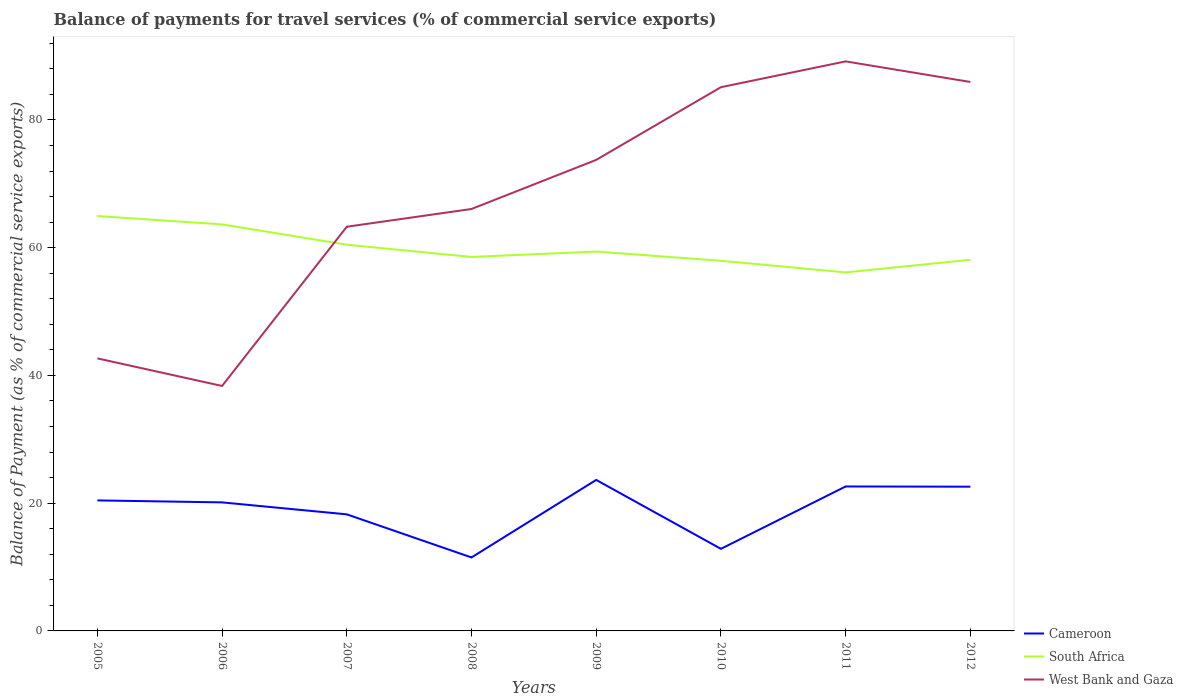How many different coloured lines are there?
Keep it short and to the point. 3. Does the line corresponding to South Africa intersect with the line corresponding to West Bank and Gaza?
Ensure brevity in your answer.  Yes. Across all years, what is the maximum balance of payments for travel services in Cameroon?
Your response must be concise. 11.5. In which year was the balance of payments for travel services in South Africa maximum?
Offer a terse response. 2011. What is the total balance of payments for travel services in South Africa in the graph?
Your answer should be compact. 0.6. What is the difference between the highest and the second highest balance of payments for travel services in South Africa?
Your response must be concise. 8.83. Is the balance of payments for travel services in West Bank and Gaza strictly greater than the balance of payments for travel services in Cameroon over the years?
Offer a terse response. No. How many lines are there?
Offer a very short reply. 3. What is the difference between two consecutive major ticks on the Y-axis?
Provide a succinct answer. 20. Are the values on the major ticks of Y-axis written in scientific E-notation?
Your response must be concise. No. Does the graph contain any zero values?
Make the answer very short. No. Where does the legend appear in the graph?
Your response must be concise. Bottom right. How are the legend labels stacked?
Your answer should be very brief. Vertical. What is the title of the graph?
Make the answer very short. Balance of payments for travel services (% of commercial service exports). Does "Cambodia" appear as one of the legend labels in the graph?
Provide a succinct answer. No. What is the label or title of the Y-axis?
Ensure brevity in your answer.  Balance of Payment (as % of commercial service exports). What is the Balance of Payment (as % of commercial service exports) of Cameroon in 2005?
Your answer should be compact. 20.43. What is the Balance of Payment (as % of commercial service exports) in South Africa in 2005?
Your answer should be compact. 64.96. What is the Balance of Payment (as % of commercial service exports) of West Bank and Gaza in 2005?
Ensure brevity in your answer.  42.67. What is the Balance of Payment (as % of commercial service exports) in Cameroon in 2006?
Your answer should be very brief. 20.13. What is the Balance of Payment (as % of commercial service exports) of South Africa in 2006?
Offer a terse response. 63.65. What is the Balance of Payment (as % of commercial service exports) of West Bank and Gaza in 2006?
Keep it short and to the point. 38.35. What is the Balance of Payment (as % of commercial service exports) in Cameroon in 2007?
Offer a very short reply. 18.25. What is the Balance of Payment (as % of commercial service exports) of South Africa in 2007?
Provide a succinct answer. 60.46. What is the Balance of Payment (as % of commercial service exports) in West Bank and Gaza in 2007?
Your answer should be compact. 63.28. What is the Balance of Payment (as % of commercial service exports) of Cameroon in 2008?
Provide a short and direct response. 11.5. What is the Balance of Payment (as % of commercial service exports) in South Africa in 2008?
Your answer should be compact. 58.55. What is the Balance of Payment (as % of commercial service exports) of West Bank and Gaza in 2008?
Your response must be concise. 66.06. What is the Balance of Payment (as % of commercial service exports) of Cameroon in 2009?
Your answer should be compact. 23.64. What is the Balance of Payment (as % of commercial service exports) of South Africa in 2009?
Ensure brevity in your answer.  59.4. What is the Balance of Payment (as % of commercial service exports) in West Bank and Gaza in 2009?
Offer a very short reply. 73.75. What is the Balance of Payment (as % of commercial service exports) of Cameroon in 2010?
Ensure brevity in your answer.  12.85. What is the Balance of Payment (as % of commercial service exports) in South Africa in 2010?
Your response must be concise. 57.95. What is the Balance of Payment (as % of commercial service exports) in West Bank and Gaza in 2010?
Your answer should be very brief. 85.13. What is the Balance of Payment (as % of commercial service exports) of Cameroon in 2011?
Offer a terse response. 22.62. What is the Balance of Payment (as % of commercial service exports) in South Africa in 2011?
Offer a terse response. 56.14. What is the Balance of Payment (as % of commercial service exports) of West Bank and Gaza in 2011?
Your answer should be very brief. 89.17. What is the Balance of Payment (as % of commercial service exports) of Cameroon in 2012?
Keep it short and to the point. 22.58. What is the Balance of Payment (as % of commercial service exports) in South Africa in 2012?
Provide a succinct answer. 58.11. What is the Balance of Payment (as % of commercial service exports) of West Bank and Gaza in 2012?
Provide a succinct answer. 85.95. Across all years, what is the maximum Balance of Payment (as % of commercial service exports) in Cameroon?
Your answer should be very brief. 23.64. Across all years, what is the maximum Balance of Payment (as % of commercial service exports) of South Africa?
Ensure brevity in your answer.  64.96. Across all years, what is the maximum Balance of Payment (as % of commercial service exports) in West Bank and Gaza?
Provide a succinct answer. 89.17. Across all years, what is the minimum Balance of Payment (as % of commercial service exports) of Cameroon?
Keep it short and to the point. 11.5. Across all years, what is the minimum Balance of Payment (as % of commercial service exports) in South Africa?
Provide a succinct answer. 56.14. Across all years, what is the minimum Balance of Payment (as % of commercial service exports) of West Bank and Gaza?
Make the answer very short. 38.35. What is the total Balance of Payment (as % of commercial service exports) in Cameroon in the graph?
Give a very brief answer. 152.01. What is the total Balance of Payment (as % of commercial service exports) in South Africa in the graph?
Keep it short and to the point. 479.22. What is the total Balance of Payment (as % of commercial service exports) in West Bank and Gaza in the graph?
Keep it short and to the point. 544.36. What is the difference between the Balance of Payment (as % of commercial service exports) of Cameroon in 2005 and that in 2006?
Offer a terse response. 0.31. What is the difference between the Balance of Payment (as % of commercial service exports) of South Africa in 2005 and that in 2006?
Make the answer very short. 1.31. What is the difference between the Balance of Payment (as % of commercial service exports) in West Bank and Gaza in 2005 and that in 2006?
Offer a terse response. 4.32. What is the difference between the Balance of Payment (as % of commercial service exports) of Cameroon in 2005 and that in 2007?
Offer a terse response. 2.18. What is the difference between the Balance of Payment (as % of commercial service exports) of South Africa in 2005 and that in 2007?
Your answer should be compact. 4.5. What is the difference between the Balance of Payment (as % of commercial service exports) of West Bank and Gaza in 2005 and that in 2007?
Offer a terse response. -20.61. What is the difference between the Balance of Payment (as % of commercial service exports) in Cameroon in 2005 and that in 2008?
Provide a succinct answer. 8.93. What is the difference between the Balance of Payment (as % of commercial service exports) of South Africa in 2005 and that in 2008?
Make the answer very short. 6.41. What is the difference between the Balance of Payment (as % of commercial service exports) in West Bank and Gaza in 2005 and that in 2008?
Provide a short and direct response. -23.39. What is the difference between the Balance of Payment (as % of commercial service exports) of Cameroon in 2005 and that in 2009?
Provide a succinct answer. -3.21. What is the difference between the Balance of Payment (as % of commercial service exports) of South Africa in 2005 and that in 2009?
Provide a succinct answer. 5.56. What is the difference between the Balance of Payment (as % of commercial service exports) of West Bank and Gaza in 2005 and that in 2009?
Make the answer very short. -31.08. What is the difference between the Balance of Payment (as % of commercial service exports) in Cameroon in 2005 and that in 2010?
Your answer should be compact. 7.58. What is the difference between the Balance of Payment (as % of commercial service exports) of South Africa in 2005 and that in 2010?
Give a very brief answer. 7.01. What is the difference between the Balance of Payment (as % of commercial service exports) in West Bank and Gaza in 2005 and that in 2010?
Provide a short and direct response. -42.46. What is the difference between the Balance of Payment (as % of commercial service exports) in Cameroon in 2005 and that in 2011?
Your response must be concise. -2.18. What is the difference between the Balance of Payment (as % of commercial service exports) in South Africa in 2005 and that in 2011?
Offer a very short reply. 8.83. What is the difference between the Balance of Payment (as % of commercial service exports) in West Bank and Gaza in 2005 and that in 2011?
Provide a succinct answer. -46.5. What is the difference between the Balance of Payment (as % of commercial service exports) in Cameroon in 2005 and that in 2012?
Make the answer very short. -2.15. What is the difference between the Balance of Payment (as % of commercial service exports) in South Africa in 2005 and that in 2012?
Offer a very short reply. 6.85. What is the difference between the Balance of Payment (as % of commercial service exports) of West Bank and Gaza in 2005 and that in 2012?
Keep it short and to the point. -43.28. What is the difference between the Balance of Payment (as % of commercial service exports) in Cameroon in 2006 and that in 2007?
Your answer should be very brief. 1.87. What is the difference between the Balance of Payment (as % of commercial service exports) of South Africa in 2006 and that in 2007?
Provide a short and direct response. 3.18. What is the difference between the Balance of Payment (as % of commercial service exports) of West Bank and Gaza in 2006 and that in 2007?
Keep it short and to the point. -24.93. What is the difference between the Balance of Payment (as % of commercial service exports) in Cameroon in 2006 and that in 2008?
Make the answer very short. 8.62. What is the difference between the Balance of Payment (as % of commercial service exports) of South Africa in 2006 and that in 2008?
Your response must be concise. 5.1. What is the difference between the Balance of Payment (as % of commercial service exports) in West Bank and Gaza in 2006 and that in 2008?
Your answer should be very brief. -27.71. What is the difference between the Balance of Payment (as % of commercial service exports) of Cameroon in 2006 and that in 2009?
Your answer should be compact. -3.52. What is the difference between the Balance of Payment (as % of commercial service exports) of South Africa in 2006 and that in 2009?
Make the answer very short. 4.25. What is the difference between the Balance of Payment (as % of commercial service exports) of West Bank and Gaza in 2006 and that in 2009?
Give a very brief answer. -35.4. What is the difference between the Balance of Payment (as % of commercial service exports) in Cameroon in 2006 and that in 2010?
Provide a short and direct response. 7.27. What is the difference between the Balance of Payment (as % of commercial service exports) of South Africa in 2006 and that in 2010?
Your response must be concise. 5.7. What is the difference between the Balance of Payment (as % of commercial service exports) in West Bank and Gaza in 2006 and that in 2010?
Offer a very short reply. -46.78. What is the difference between the Balance of Payment (as % of commercial service exports) in Cameroon in 2006 and that in 2011?
Give a very brief answer. -2.49. What is the difference between the Balance of Payment (as % of commercial service exports) in South Africa in 2006 and that in 2011?
Your response must be concise. 7.51. What is the difference between the Balance of Payment (as % of commercial service exports) in West Bank and Gaza in 2006 and that in 2011?
Your response must be concise. -50.82. What is the difference between the Balance of Payment (as % of commercial service exports) of Cameroon in 2006 and that in 2012?
Ensure brevity in your answer.  -2.46. What is the difference between the Balance of Payment (as % of commercial service exports) of South Africa in 2006 and that in 2012?
Give a very brief answer. 5.54. What is the difference between the Balance of Payment (as % of commercial service exports) of West Bank and Gaza in 2006 and that in 2012?
Keep it short and to the point. -47.6. What is the difference between the Balance of Payment (as % of commercial service exports) of Cameroon in 2007 and that in 2008?
Offer a terse response. 6.75. What is the difference between the Balance of Payment (as % of commercial service exports) in South Africa in 2007 and that in 2008?
Give a very brief answer. 1.91. What is the difference between the Balance of Payment (as % of commercial service exports) of West Bank and Gaza in 2007 and that in 2008?
Ensure brevity in your answer.  -2.78. What is the difference between the Balance of Payment (as % of commercial service exports) in Cameroon in 2007 and that in 2009?
Offer a terse response. -5.39. What is the difference between the Balance of Payment (as % of commercial service exports) in South Africa in 2007 and that in 2009?
Offer a terse response. 1.07. What is the difference between the Balance of Payment (as % of commercial service exports) of West Bank and Gaza in 2007 and that in 2009?
Offer a terse response. -10.47. What is the difference between the Balance of Payment (as % of commercial service exports) in Cameroon in 2007 and that in 2010?
Your answer should be very brief. 5.4. What is the difference between the Balance of Payment (as % of commercial service exports) in South Africa in 2007 and that in 2010?
Keep it short and to the point. 2.51. What is the difference between the Balance of Payment (as % of commercial service exports) in West Bank and Gaza in 2007 and that in 2010?
Keep it short and to the point. -21.85. What is the difference between the Balance of Payment (as % of commercial service exports) in Cameroon in 2007 and that in 2011?
Make the answer very short. -4.36. What is the difference between the Balance of Payment (as % of commercial service exports) in South Africa in 2007 and that in 2011?
Offer a very short reply. 4.33. What is the difference between the Balance of Payment (as % of commercial service exports) in West Bank and Gaza in 2007 and that in 2011?
Your answer should be very brief. -25.89. What is the difference between the Balance of Payment (as % of commercial service exports) of Cameroon in 2007 and that in 2012?
Provide a short and direct response. -4.33. What is the difference between the Balance of Payment (as % of commercial service exports) in South Africa in 2007 and that in 2012?
Give a very brief answer. 2.36. What is the difference between the Balance of Payment (as % of commercial service exports) in West Bank and Gaza in 2007 and that in 2012?
Provide a succinct answer. -22.67. What is the difference between the Balance of Payment (as % of commercial service exports) of Cameroon in 2008 and that in 2009?
Provide a short and direct response. -12.14. What is the difference between the Balance of Payment (as % of commercial service exports) of South Africa in 2008 and that in 2009?
Ensure brevity in your answer.  -0.84. What is the difference between the Balance of Payment (as % of commercial service exports) of West Bank and Gaza in 2008 and that in 2009?
Your answer should be compact. -7.69. What is the difference between the Balance of Payment (as % of commercial service exports) of Cameroon in 2008 and that in 2010?
Offer a very short reply. -1.35. What is the difference between the Balance of Payment (as % of commercial service exports) in South Africa in 2008 and that in 2010?
Offer a very short reply. 0.6. What is the difference between the Balance of Payment (as % of commercial service exports) in West Bank and Gaza in 2008 and that in 2010?
Ensure brevity in your answer.  -19.07. What is the difference between the Balance of Payment (as % of commercial service exports) in Cameroon in 2008 and that in 2011?
Offer a terse response. -11.11. What is the difference between the Balance of Payment (as % of commercial service exports) in South Africa in 2008 and that in 2011?
Your answer should be very brief. 2.42. What is the difference between the Balance of Payment (as % of commercial service exports) of West Bank and Gaza in 2008 and that in 2011?
Give a very brief answer. -23.11. What is the difference between the Balance of Payment (as % of commercial service exports) in Cameroon in 2008 and that in 2012?
Offer a terse response. -11.08. What is the difference between the Balance of Payment (as % of commercial service exports) in South Africa in 2008 and that in 2012?
Provide a succinct answer. 0.45. What is the difference between the Balance of Payment (as % of commercial service exports) of West Bank and Gaza in 2008 and that in 2012?
Offer a very short reply. -19.89. What is the difference between the Balance of Payment (as % of commercial service exports) in Cameroon in 2009 and that in 2010?
Keep it short and to the point. 10.79. What is the difference between the Balance of Payment (as % of commercial service exports) of South Africa in 2009 and that in 2010?
Provide a short and direct response. 1.45. What is the difference between the Balance of Payment (as % of commercial service exports) in West Bank and Gaza in 2009 and that in 2010?
Keep it short and to the point. -11.38. What is the difference between the Balance of Payment (as % of commercial service exports) of Cameroon in 2009 and that in 2011?
Your answer should be compact. 1.03. What is the difference between the Balance of Payment (as % of commercial service exports) in South Africa in 2009 and that in 2011?
Give a very brief answer. 3.26. What is the difference between the Balance of Payment (as % of commercial service exports) of West Bank and Gaza in 2009 and that in 2011?
Ensure brevity in your answer.  -15.42. What is the difference between the Balance of Payment (as % of commercial service exports) in Cameroon in 2009 and that in 2012?
Your answer should be compact. 1.06. What is the difference between the Balance of Payment (as % of commercial service exports) in South Africa in 2009 and that in 2012?
Offer a very short reply. 1.29. What is the difference between the Balance of Payment (as % of commercial service exports) of West Bank and Gaza in 2009 and that in 2012?
Offer a very short reply. -12.2. What is the difference between the Balance of Payment (as % of commercial service exports) in Cameroon in 2010 and that in 2011?
Your answer should be compact. -9.77. What is the difference between the Balance of Payment (as % of commercial service exports) in South Africa in 2010 and that in 2011?
Make the answer very short. 1.82. What is the difference between the Balance of Payment (as % of commercial service exports) of West Bank and Gaza in 2010 and that in 2011?
Your answer should be very brief. -4.04. What is the difference between the Balance of Payment (as % of commercial service exports) in Cameroon in 2010 and that in 2012?
Your response must be concise. -9.73. What is the difference between the Balance of Payment (as % of commercial service exports) of South Africa in 2010 and that in 2012?
Provide a succinct answer. -0.15. What is the difference between the Balance of Payment (as % of commercial service exports) of West Bank and Gaza in 2010 and that in 2012?
Provide a succinct answer. -0.82. What is the difference between the Balance of Payment (as % of commercial service exports) of Cameroon in 2011 and that in 2012?
Provide a succinct answer. 0.03. What is the difference between the Balance of Payment (as % of commercial service exports) of South Africa in 2011 and that in 2012?
Your answer should be very brief. -1.97. What is the difference between the Balance of Payment (as % of commercial service exports) in West Bank and Gaza in 2011 and that in 2012?
Ensure brevity in your answer.  3.22. What is the difference between the Balance of Payment (as % of commercial service exports) in Cameroon in 2005 and the Balance of Payment (as % of commercial service exports) in South Africa in 2006?
Offer a terse response. -43.21. What is the difference between the Balance of Payment (as % of commercial service exports) in Cameroon in 2005 and the Balance of Payment (as % of commercial service exports) in West Bank and Gaza in 2006?
Offer a terse response. -17.92. What is the difference between the Balance of Payment (as % of commercial service exports) of South Africa in 2005 and the Balance of Payment (as % of commercial service exports) of West Bank and Gaza in 2006?
Offer a terse response. 26.61. What is the difference between the Balance of Payment (as % of commercial service exports) in Cameroon in 2005 and the Balance of Payment (as % of commercial service exports) in South Africa in 2007?
Keep it short and to the point. -40.03. What is the difference between the Balance of Payment (as % of commercial service exports) of Cameroon in 2005 and the Balance of Payment (as % of commercial service exports) of West Bank and Gaza in 2007?
Offer a terse response. -42.85. What is the difference between the Balance of Payment (as % of commercial service exports) in South Africa in 2005 and the Balance of Payment (as % of commercial service exports) in West Bank and Gaza in 2007?
Offer a terse response. 1.68. What is the difference between the Balance of Payment (as % of commercial service exports) of Cameroon in 2005 and the Balance of Payment (as % of commercial service exports) of South Africa in 2008?
Provide a succinct answer. -38.12. What is the difference between the Balance of Payment (as % of commercial service exports) of Cameroon in 2005 and the Balance of Payment (as % of commercial service exports) of West Bank and Gaza in 2008?
Your answer should be very brief. -45.62. What is the difference between the Balance of Payment (as % of commercial service exports) in South Africa in 2005 and the Balance of Payment (as % of commercial service exports) in West Bank and Gaza in 2008?
Provide a short and direct response. -1.1. What is the difference between the Balance of Payment (as % of commercial service exports) of Cameroon in 2005 and the Balance of Payment (as % of commercial service exports) of South Africa in 2009?
Your answer should be compact. -38.96. What is the difference between the Balance of Payment (as % of commercial service exports) of Cameroon in 2005 and the Balance of Payment (as % of commercial service exports) of West Bank and Gaza in 2009?
Offer a very short reply. -53.31. What is the difference between the Balance of Payment (as % of commercial service exports) in South Africa in 2005 and the Balance of Payment (as % of commercial service exports) in West Bank and Gaza in 2009?
Offer a terse response. -8.79. What is the difference between the Balance of Payment (as % of commercial service exports) of Cameroon in 2005 and the Balance of Payment (as % of commercial service exports) of South Africa in 2010?
Offer a very short reply. -37.52. What is the difference between the Balance of Payment (as % of commercial service exports) in Cameroon in 2005 and the Balance of Payment (as % of commercial service exports) in West Bank and Gaza in 2010?
Your response must be concise. -64.7. What is the difference between the Balance of Payment (as % of commercial service exports) in South Africa in 2005 and the Balance of Payment (as % of commercial service exports) in West Bank and Gaza in 2010?
Give a very brief answer. -20.17. What is the difference between the Balance of Payment (as % of commercial service exports) in Cameroon in 2005 and the Balance of Payment (as % of commercial service exports) in South Africa in 2011?
Your answer should be very brief. -35.7. What is the difference between the Balance of Payment (as % of commercial service exports) of Cameroon in 2005 and the Balance of Payment (as % of commercial service exports) of West Bank and Gaza in 2011?
Your answer should be very brief. -68.74. What is the difference between the Balance of Payment (as % of commercial service exports) of South Africa in 2005 and the Balance of Payment (as % of commercial service exports) of West Bank and Gaza in 2011?
Your answer should be compact. -24.21. What is the difference between the Balance of Payment (as % of commercial service exports) of Cameroon in 2005 and the Balance of Payment (as % of commercial service exports) of South Africa in 2012?
Give a very brief answer. -37.67. What is the difference between the Balance of Payment (as % of commercial service exports) in Cameroon in 2005 and the Balance of Payment (as % of commercial service exports) in West Bank and Gaza in 2012?
Your response must be concise. -65.51. What is the difference between the Balance of Payment (as % of commercial service exports) of South Africa in 2005 and the Balance of Payment (as % of commercial service exports) of West Bank and Gaza in 2012?
Your answer should be very brief. -20.99. What is the difference between the Balance of Payment (as % of commercial service exports) of Cameroon in 2006 and the Balance of Payment (as % of commercial service exports) of South Africa in 2007?
Offer a very short reply. -40.34. What is the difference between the Balance of Payment (as % of commercial service exports) in Cameroon in 2006 and the Balance of Payment (as % of commercial service exports) in West Bank and Gaza in 2007?
Provide a succinct answer. -43.15. What is the difference between the Balance of Payment (as % of commercial service exports) in South Africa in 2006 and the Balance of Payment (as % of commercial service exports) in West Bank and Gaza in 2007?
Give a very brief answer. 0.37. What is the difference between the Balance of Payment (as % of commercial service exports) in Cameroon in 2006 and the Balance of Payment (as % of commercial service exports) in South Africa in 2008?
Offer a terse response. -38.43. What is the difference between the Balance of Payment (as % of commercial service exports) of Cameroon in 2006 and the Balance of Payment (as % of commercial service exports) of West Bank and Gaza in 2008?
Your answer should be very brief. -45.93. What is the difference between the Balance of Payment (as % of commercial service exports) of South Africa in 2006 and the Balance of Payment (as % of commercial service exports) of West Bank and Gaza in 2008?
Ensure brevity in your answer.  -2.41. What is the difference between the Balance of Payment (as % of commercial service exports) of Cameroon in 2006 and the Balance of Payment (as % of commercial service exports) of South Africa in 2009?
Keep it short and to the point. -39.27. What is the difference between the Balance of Payment (as % of commercial service exports) in Cameroon in 2006 and the Balance of Payment (as % of commercial service exports) in West Bank and Gaza in 2009?
Keep it short and to the point. -53.62. What is the difference between the Balance of Payment (as % of commercial service exports) in South Africa in 2006 and the Balance of Payment (as % of commercial service exports) in West Bank and Gaza in 2009?
Provide a succinct answer. -10.1. What is the difference between the Balance of Payment (as % of commercial service exports) in Cameroon in 2006 and the Balance of Payment (as % of commercial service exports) in South Africa in 2010?
Give a very brief answer. -37.83. What is the difference between the Balance of Payment (as % of commercial service exports) in Cameroon in 2006 and the Balance of Payment (as % of commercial service exports) in West Bank and Gaza in 2010?
Your response must be concise. -65.01. What is the difference between the Balance of Payment (as % of commercial service exports) of South Africa in 2006 and the Balance of Payment (as % of commercial service exports) of West Bank and Gaza in 2010?
Your answer should be very brief. -21.48. What is the difference between the Balance of Payment (as % of commercial service exports) of Cameroon in 2006 and the Balance of Payment (as % of commercial service exports) of South Africa in 2011?
Your response must be concise. -36.01. What is the difference between the Balance of Payment (as % of commercial service exports) in Cameroon in 2006 and the Balance of Payment (as % of commercial service exports) in West Bank and Gaza in 2011?
Ensure brevity in your answer.  -69.05. What is the difference between the Balance of Payment (as % of commercial service exports) of South Africa in 2006 and the Balance of Payment (as % of commercial service exports) of West Bank and Gaza in 2011?
Give a very brief answer. -25.52. What is the difference between the Balance of Payment (as % of commercial service exports) in Cameroon in 2006 and the Balance of Payment (as % of commercial service exports) in South Africa in 2012?
Your answer should be very brief. -37.98. What is the difference between the Balance of Payment (as % of commercial service exports) of Cameroon in 2006 and the Balance of Payment (as % of commercial service exports) of West Bank and Gaza in 2012?
Your response must be concise. -65.82. What is the difference between the Balance of Payment (as % of commercial service exports) of South Africa in 2006 and the Balance of Payment (as % of commercial service exports) of West Bank and Gaza in 2012?
Provide a short and direct response. -22.3. What is the difference between the Balance of Payment (as % of commercial service exports) of Cameroon in 2007 and the Balance of Payment (as % of commercial service exports) of South Africa in 2008?
Give a very brief answer. -40.3. What is the difference between the Balance of Payment (as % of commercial service exports) in Cameroon in 2007 and the Balance of Payment (as % of commercial service exports) in West Bank and Gaza in 2008?
Your answer should be compact. -47.81. What is the difference between the Balance of Payment (as % of commercial service exports) in South Africa in 2007 and the Balance of Payment (as % of commercial service exports) in West Bank and Gaza in 2008?
Keep it short and to the point. -5.59. What is the difference between the Balance of Payment (as % of commercial service exports) in Cameroon in 2007 and the Balance of Payment (as % of commercial service exports) in South Africa in 2009?
Provide a succinct answer. -41.15. What is the difference between the Balance of Payment (as % of commercial service exports) in Cameroon in 2007 and the Balance of Payment (as % of commercial service exports) in West Bank and Gaza in 2009?
Provide a short and direct response. -55.5. What is the difference between the Balance of Payment (as % of commercial service exports) of South Africa in 2007 and the Balance of Payment (as % of commercial service exports) of West Bank and Gaza in 2009?
Give a very brief answer. -13.28. What is the difference between the Balance of Payment (as % of commercial service exports) of Cameroon in 2007 and the Balance of Payment (as % of commercial service exports) of South Africa in 2010?
Ensure brevity in your answer.  -39.7. What is the difference between the Balance of Payment (as % of commercial service exports) in Cameroon in 2007 and the Balance of Payment (as % of commercial service exports) in West Bank and Gaza in 2010?
Make the answer very short. -66.88. What is the difference between the Balance of Payment (as % of commercial service exports) of South Africa in 2007 and the Balance of Payment (as % of commercial service exports) of West Bank and Gaza in 2010?
Your answer should be compact. -24.67. What is the difference between the Balance of Payment (as % of commercial service exports) of Cameroon in 2007 and the Balance of Payment (as % of commercial service exports) of South Africa in 2011?
Offer a terse response. -37.88. What is the difference between the Balance of Payment (as % of commercial service exports) of Cameroon in 2007 and the Balance of Payment (as % of commercial service exports) of West Bank and Gaza in 2011?
Your answer should be very brief. -70.92. What is the difference between the Balance of Payment (as % of commercial service exports) of South Africa in 2007 and the Balance of Payment (as % of commercial service exports) of West Bank and Gaza in 2011?
Keep it short and to the point. -28.71. What is the difference between the Balance of Payment (as % of commercial service exports) in Cameroon in 2007 and the Balance of Payment (as % of commercial service exports) in South Africa in 2012?
Provide a short and direct response. -39.85. What is the difference between the Balance of Payment (as % of commercial service exports) in Cameroon in 2007 and the Balance of Payment (as % of commercial service exports) in West Bank and Gaza in 2012?
Provide a succinct answer. -67.7. What is the difference between the Balance of Payment (as % of commercial service exports) in South Africa in 2007 and the Balance of Payment (as % of commercial service exports) in West Bank and Gaza in 2012?
Provide a short and direct response. -25.48. What is the difference between the Balance of Payment (as % of commercial service exports) in Cameroon in 2008 and the Balance of Payment (as % of commercial service exports) in South Africa in 2009?
Your answer should be very brief. -47.89. What is the difference between the Balance of Payment (as % of commercial service exports) in Cameroon in 2008 and the Balance of Payment (as % of commercial service exports) in West Bank and Gaza in 2009?
Give a very brief answer. -62.25. What is the difference between the Balance of Payment (as % of commercial service exports) of South Africa in 2008 and the Balance of Payment (as % of commercial service exports) of West Bank and Gaza in 2009?
Your response must be concise. -15.2. What is the difference between the Balance of Payment (as % of commercial service exports) of Cameroon in 2008 and the Balance of Payment (as % of commercial service exports) of South Africa in 2010?
Your response must be concise. -46.45. What is the difference between the Balance of Payment (as % of commercial service exports) in Cameroon in 2008 and the Balance of Payment (as % of commercial service exports) in West Bank and Gaza in 2010?
Provide a short and direct response. -73.63. What is the difference between the Balance of Payment (as % of commercial service exports) of South Africa in 2008 and the Balance of Payment (as % of commercial service exports) of West Bank and Gaza in 2010?
Offer a terse response. -26.58. What is the difference between the Balance of Payment (as % of commercial service exports) of Cameroon in 2008 and the Balance of Payment (as % of commercial service exports) of South Africa in 2011?
Provide a succinct answer. -44.63. What is the difference between the Balance of Payment (as % of commercial service exports) in Cameroon in 2008 and the Balance of Payment (as % of commercial service exports) in West Bank and Gaza in 2011?
Ensure brevity in your answer.  -77.67. What is the difference between the Balance of Payment (as % of commercial service exports) in South Africa in 2008 and the Balance of Payment (as % of commercial service exports) in West Bank and Gaza in 2011?
Your answer should be very brief. -30.62. What is the difference between the Balance of Payment (as % of commercial service exports) in Cameroon in 2008 and the Balance of Payment (as % of commercial service exports) in South Africa in 2012?
Your answer should be very brief. -46.6. What is the difference between the Balance of Payment (as % of commercial service exports) of Cameroon in 2008 and the Balance of Payment (as % of commercial service exports) of West Bank and Gaza in 2012?
Give a very brief answer. -74.44. What is the difference between the Balance of Payment (as % of commercial service exports) in South Africa in 2008 and the Balance of Payment (as % of commercial service exports) in West Bank and Gaza in 2012?
Ensure brevity in your answer.  -27.39. What is the difference between the Balance of Payment (as % of commercial service exports) of Cameroon in 2009 and the Balance of Payment (as % of commercial service exports) of South Africa in 2010?
Your response must be concise. -34.31. What is the difference between the Balance of Payment (as % of commercial service exports) of Cameroon in 2009 and the Balance of Payment (as % of commercial service exports) of West Bank and Gaza in 2010?
Provide a succinct answer. -61.49. What is the difference between the Balance of Payment (as % of commercial service exports) of South Africa in 2009 and the Balance of Payment (as % of commercial service exports) of West Bank and Gaza in 2010?
Your answer should be very brief. -25.73. What is the difference between the Balance of Payment (as % of commercial service exports) in Cameroon in 2009 and the Balance of Payment (as % of commercial service exports) in South Africa in 2011?
Make the answer very short. -32.49. What is the difference between the Balance of Payment (as % of commercial service exports) in Cameroon in 2009 and the Balance of Payment (as % of commercial service exports) in West Bank and Gaza in 2011?
Your response must be concise. -65.53. What is the difference between the Balance of Payment (as % of commercial service exports) in South Africa in 2009 and the Balance of Payment (as % of commercial service exports) in West Bank and Gaza in 2011?
Offer a very short reply. -29.77. What is the difference between the Balance of Payment (as % of commercial service exports) in Cameroon in 2009 and the Balance of Payment (as % of commercial service exports) in South Africa in 2012?
Provide a succinct answer. -34.46. What is the difference between the Balance of Payment (as % of commercial service exports) of Cameroon in 2009 and the Balance of Payment (as % of commercial service exports) of West Bank and Gaza in 2012?
Make the answer very short. -62.31. What is the difference between the Balance of Payment (as % of commercial service exports) of South Africa in 2009 and the Balance of Payment (as % of commercial service exports) of West Bank and Gaza in 2012?
Provide a succinct answer. -26.55. What is the difference between the Balance of Payment (as % of commercial service exports) in Cameroon in 2010 and the Balance of Payment (as % of commercial service exports) in South Africa in 2011?
Offer a terse response. -43.28. What is the difference between the Balance of Payment (as % of commercial service exports) in Cameroon in 2010 and the Balance of Payment (as % of commercial service exports) in West Bank and Gaza in 2011?
Make the answer very short. -76.32. What is the difference between the Balance of Payment (as % of commercial service exports) of South Africa in 2010 and the Balance of Payment (as % of commercial service exports) of West Bank and Gaza in 2011?
Your response must be concise. -31.22. What is the difference between the Balance of Payment (as % of commercial service exports) in Cameroon in 2010 and the Balance of Payment (as % of commercial service exports) in South Africa in 2012?
Ensure brevity in your answer.  -45.26. What is the difference between the Balance of Payment (as % of commercial service exports) of Cameroon in 2010 and the Balance of Payment (as % of commercial service exports) of West Bank and Gaza in 2012?
Keep it short and to the point. -73.1. What is the difference between the Balance of Payment (as % of commercial service exports) of South Africa in 2010 and the Balance of Payment (as % of commercial service exports) of West Bank and Gaza in 2012?
Your answer should be very brief. -28. What is the difference between the Balance of Payment (as % of commercial service exports) of Cameroon in 2011 and the Balance of Payment (as % of commercial service exports) of South Africa in 2012?
Your answer should be compact. -35.49. What is the difference between the Balance of Payment (as % of commercial service exports) of Cameroon in 2011 and the Balance of Payment (as % of commercial service exports) of West Bank and Gaza in 2012?
Offer a very short reply. -63.33. What is the difference between the Balance of Payment (as % of commercial service exports) of South Africa in 2011 and the Balance of Payment (as % of commercial service exports) of West Bank and Gaza in 2012?
Your response must be concise. -29.81. What is the average Balance of Payment (as % of commercial service exports) in Cameroon per year?
Offer a very short reply. 19. What is the average Balance of Payment (as % of commercial service exports) of South Africa per year?
Offer a very short reply. 59.9. What is the average Balance of Payment (as % of commercial service exports) in West Bank and Gaza per year?
Give a very brief answer. 68.05. In the year 2005, what is the difference between the Balance of Payment (as % of commercial service exports) in Cameroon and Balance of Payment (as % of commercial service exports) in South Africa?
Keep it short and to the point. -44.53. In the year 2005, what is the difference between the Balance of Payment (as % of commercial service exports) of Cameroon and Balance of Payment (as % of commercial service exports) of West Bank and Gaza?
Provide a short and direct response. -22.24. In the year 2005, what is the difference between the Balance of Payment (as % of commercial service exports) in South Africa and Balance of Payment (as % of commercial service exports) in West Bank and Gaza?
Offer a very short reply. 22.29. In the year 2006, what is the difference between the Balance of Payment (as % of commercial service exports) of Cameroon and Balance of Payment (as % of commercial service exports) of South Africa?
Ensure brevity in your answer.  -43.52. In the year 2006, what is the difference between the Balance of Payment (as % of commercial service exports) in Cameroon and Balance of Payment (as % of commercial service exports) in West Bank and Gaza?
Keep it short and to the point. -18.23. In the year 2006, what is the difference between the Balance of Payment (as % of commercial service exports) of South Africa and Balance of Payment (as % of commercial service exports) of West Bank and Gaza?
Your answer should be very brief. 25.3. In the year 2007, what is the difference between the Balance of Payment (as % of commercial service exports) of Cameroon and Balance of Payment (as % of commercial service exports) of South Africa?
Your response must be concise. -42.21. In the year 2007, what is the difference between the Balance of Payment (as % of commercial service exports) of Cameroon and Balance of Payment (as % of commercial service exports) of West Bank and Gaza?
Give a very brief answer. -45.03. In the year 2007, what is the difference between the Balance of Payment (as % of commercial service exports) in South Africa and Balance of Payment (as % of commercial service exports) in West Bank and Gaza?
Your answer should be compact. -2.82. In the year 2008, what is the difference between the Balance of Payment (as % of commercial service exports) in Cameroon and Balance of Payment (as % of commercial service exports) in South Africa?
Ensure brevity in your answer.  -47.05. In the year 2008, what is the difference between the Balance of Payment (as % of commercial service exports) of Cameroon and Balance of Payment (as % of commercial service exports) of West Bank and Gaza?
Provide a succinct answer. -54.56. In the year 2008, what is the difference between the Balance of Payment (as % of commercial service exports) in South Africa and Balance of Payment (as % of commercial service exports) in West Bank and Gaza?
Give a very brief answer. -7.51. In the year 2009, what is the difference between the Balance of Payment (as % of commercial service exports) of Cameroon and Balance of Payment (as % of commercial service exports) of South Africa?
Ensure brevity in your answer.  -35.76. In the year 2009, what is the difference between the Balance of Payment (as % of commercial service exports) in Cameroon and Balance of Payment (as % of commercial service exports) in West Bank and Gaza?
Keep it short and to the point. -50.11. In the year 2009, what is the difference between the Balance of Payment (as % of commercial service exports) in South Africa and Balance of Payment (as % of commercial service exports) in West Bank and Gaza?
Offer a terse response. -14.35. In the year 2010, what is the difference between the Balance of Payment (as % of commercial service exports) in Cameroon and Balance of Payment (as % of commercial service exports) in South Africa?
Your response must be concise. -45.1. In the year 2010, what is the difference between the Balance of Payment (as % of commercial service exports) of Cameroon and Balance of Payment (as % of commercial service exports) of West Bank and Gaza?
Provide a succinct answer. -72.28. In the year 2010, what is the difference between the Balance of Payment (as % of commercial service exports) of South Africa and Balance of Payment (as % of commercial service exports) of West Bank and Gaza?
Provide a succinct answer. -27.18. In the year 2011, what is the difference between the Balance of Payment (as % of commercial service exports) of Cameroon and Balance of Payment (as % of commercial service exports) of South Africa?
Provide a succinct answer. -33.52. In the year 2011, what is the difference between the Balance of Payment (as % of commercial service exports) in Cameroon and Balance of Payment (as % of commercial service exports) in West Bank and Gaza?
Provide a succinct answer. -66.55. In the year 2011, what is the difference between the Balance of Payment (as % of commercial service exports) in South Africa and Balance of Payment (as % of commercial service exports) in West Bank and Gaza?
Offer a terse response. -33.04. In the year 2012, what is the difference between the Balance of Payment (as % of commercial service exports) in Cameroon and Balance of Payment (as % of commercial service exports) in South Africa?
Make the answer very short. -35.52. In the year 2012, what is the difference between the Balance of Payment (as % of commercial service exports) of Cameroon and Balance of Payment (as % of commercial service exports) of West Bank and Gaza?
Your answer should be very brief. -63.37. In the year 2012, what is the difference between the Balance of Payment (as % of commercial service exports) in South Africa and Balance of Payment (as % of commercial service exports) in West Bank and Gaza?
Your answer should be compact. -27.84. What is the ratio of the Balance of Payment (as % of commercial service exports) in Cameroon in 2005 to that in 2006?
Your response must be concise. 1.02. What is the ratio of the Balance of Payment (as % of commercial service exports) in South Africa in 2005 to that in 2006?
Keep it short and to the point. 1.02. What is the ratio of the Balance of Payment (as % of commercial service exports) of West Bank and Gaza in 2005 to that in 2006?
Offer a terse response. 1.11. What is the ratio of the Balance of Payment (as % of commercial service exports) in Cameroon in 2005 to that in 2007?
Keep it short and to the point. 1.12. What is the ratio of the Balance of Payment (as % of commercial service exports) of South Africa in 2005 to that in 2007?
Your response must be concise. 1.07. What is the ratio of the Balance of Payment (as % of commercial service exports) of West Bank and Gaza in 2005 to that in 2007?
Give a very brief answer. 0.67. What is the ratio of the Balance of Payment (as % of commercial service exports) in Cameroon in 2005 to that in 2008?
Provide a succinct answer. 1.78. What is the ratio of the Balance of Payment (as % of commercial service exports) of South Africa in 2005 to that in 2008?
Provide a succinct answer. 1.11. What is the ratio of the Balance of Payment (as % of commercial service exports) in West Bank and Gaza in 2005 to that in 2008?
Your response must be concise. 0.65. What is the ratio of the Balance of Payment (as % of commercial service exports) in Cameroon in 2005 to that in 2009?
Offer a very short reply. 0.86. What is the ratio of the Balance of Payment (as % of commercial service exports) of South Africa in 2005 to that in 2009?
Your answer should be very brief. 1.09. What is the ratio of the Balance of Payment (as % of commercial service exports) in West Bank and Gaza in 2005 to that in 2009?
Keep it short and to the point. 0.58. What is the ratio of the Balance of Payment (as % of commercial service exports) of Cameroon in 2005 to that in 2010?
Your answer should be very brief. 1.59. What is the ratio of the Balance of Payment (as % of commercial service exports) of South Africa in 2005 to that in 2010?
Make the answer very short. 1.12. What is the ratio of the Balance of Payment (as % of commercial service exports) in West Bank and Gaza in 2005 to that in 2010?
Keep it short and to the point. 0.5. What is the ratio of the Balance of Payment (as % of commercial service exports) of Cameroon in 2005 to that in 2011?
Your answer should be very brief. 0.9. What is the ratio of the Balance of Payment (as % of commercial service exports) in South Africa in 2005 to that in 2011?
Make the answer very short. 1.16. What is the ratio of the Balance of Payment (as % of commercial service exports) of West Bank and Gaza in 2005 to that in 2011?
Provide a short and direct response. 0.48. What is the ratio of the Balance of Payment (as % of commercial service exports) of Cameroon in 2005 to that in 2012?
Your answer should be very brief. 0.9. What is the ratio of the Balance of Payment (as % of commercial service exports) of South Africa in 2005 to that in 2012?
Offer a terse response. 1.12. What is the ratio of the Balance of Payment (as % of commercial service exports) in West Bank and Gaza in 2005 to that in 2012?
Ensure brevity in your answer.  0.5. What is the ratio of the Balance of Payment (as % of commercial service exports) in Cameroon in 2006 to that in 2007?
Ensure brevity in your answer.  1.1. What is the ratio of the Balance of Payment (as % of commercial service exports) in South Africa in 2006 to that in 2007?
Keep it short and to the point. 1.05. What is the ratio of the Balance of Payment (as % of commercial service exports) in West Bank and Gaza in 2006 to that in 2007?
Offer a very short reply. 0.61. What is the ratio of the Balance of Payment (as % of commercial service exports) of Cameroon in 2006 to that in 2008?
Make the answer very short. 1.75. What is the ratio of the Balance of Payment (as % of commercial service exports) in South Africa in 2006 to that in 2008?
Offer a terse response. 1.09. What is the ratio of the Balance of Payment (as % of commercial service exports) in West Bank and Gaza in 2006 to that in 2008?
Provide a succinct answer. 0.58. What is the ratio of the Balance of Payment (as % of commercial service exports) in Cameroon in 2006 to that in 2009?
Provide a short and direct response. 0.85. What is the ratio of the Balance of Payment (as % of commercial service exports) of South Africa in 2006 to that in 2009?
Your answer should be very brief. 1.07. What is the ratio of the Balance of Payment (as % of commercial service exports) in West Bank and Gaza in 2006 to that in 2009?
Give a very brief answer. 0.52. What is the ratio of the Balance of Payment (as % of commercial service exports) of Cameroon in 2006 to that in 2010?
Provide a succinct answer. 1.57. What is the ratio of the Balance of Payment (as % of commercial service exports) in South Africa in 2006 to that in 2010?
Offer a very short reply. 1.1. What is the ratio of the Balance of Payment (as % of commercial service exports) in West Bank and Gaza in 2006 to that in 2010?
Offer a terse response. 0.45. What is the ratio of the Balance of Payment (as % of commercial service exports) of Cameroon in 2006 to that in 2011?
Give a very brief answer. 0.89. What is the ratio of the Balance of Payment (as % of commercial service exports) in South Africa in 2006 to that in 2011?
Offer a very short reply. 1.13. What is the ratio of the Balance of Payment (as % of commercial service exports) of West Bank and Gaza in 2006 to that in 2011?
Provide a succinct answer. 0.43. What is the ratio of the Balance of Payment (as % of commercial service exports) in Cameroon in 2006 to that in 2012?
Provide a short and direct response. 0.89. What is the ratio of the Balance of Payment (as % of commercial service exports) of South Africa in 2006 to that in 2012?
Provide a short and direct response. 1.1. What is the ratio of the Balance of Payment (as % of commercial service exports) in West Bank and Gaza in 2006 to that in 2012?
Make the answer very short. 0.45. What is the ratio of the Balance of Payment (as % of commercial service exports) in Cameroon in 2007 to that in 2008?
Provide a succinct answer. 1.59. What is the ratio of the Balance of Payment (as % of commercial service exports) in South Africa in 2007 to that in 2008?
Ensure brevity in your answer.  1.03. What is the ratio of the Balance of Payment (as % of commercial service exports) in West Bank and Gaza in 2007 to that in 2008?
Ensure brevity in your answer.  0.96. What is the ratio of the Balance of Payment (as % of commercial service exports) in Cameroon in 2007 to that in 2009?
Make the answer very short. 0.77. What is the ratio of the Balance of Payment (as % of commercial service exports) in West Bank and Gaza in 2007 to that in 2009?
Make the answer very short. 0.86. What is the ratio of the Balance of Payment (as % of commercial service exports) in Cameroon in 2007 to that in 2010?
Give a very brief answer. 1.42. What is the ratio of the Balance of Payment (as % of commercial service exports) of South Africa in 2007 to that in 2010?
Provide a succinct answer. 1.04. What is the ratio of the Balance of Payment (as % of commercial service exports) in West Bank and Gaza in 2007 to that in 2010?
Your response must be concise. 0.74. What is the ratio of the Balance of Payment (as % of commercial service exports) in Cameroon in 2007 to that in 2011?
Give a very brief answer. 0.81. What is the ratio of the Balance of Payment (as % of commercial service exports) in South Africa in 2007 to that in 2011?
Provide a succinct answer. 1.08. What is the ratio of the Balance of Payment (as % of commercial service exports) in West Bank and Gaza in 2007 to that in 2011?
Ensure brevity in your answer.  0.71. What is the ratio of the Balance of Payment (as % of commercial service exports) in Cameroon in 2007 to that in 2012?
Give a very brief answer. 0.81. What is the ratio of the Balance of Payment (as % of commercial service exports) of South Africa in 2007 to that in 2012?
Your answer should be compact. 1.04. What is the ratio of the Balance of Payment (as % of commercial service exports) in West Bank and Gaza in 2007 to that in 2012?
Provide a short and direct response. 0.74. What is the ratio of the Balance of Payment (as % of commercial service exports) in Cameroon in 2008 to that in 2009?
Keep it short and to the point. 0.49. What is the ratio of the Balance of Payment (as % of commercial service exports) of South Africa in 2008 to that in 2009?
Ensure brevity in your answer.  0.99. What is the ratio of the Balance of Payment (as % of commercial service exports) of West Bank and Gaza in 2008 to that in 2009?
Provide a short and direct response. 0.9. What is the ratio of the Balance of Payment (as % of commercial service exports) in Cameroon in 2008 to that in 2010?
Your response must be concise. 0.9. What is the ratio of the Balance of Payment (as % of commercial service exports) of South Africa in 2008 to that in 2010?
Your answer should be very brief. 1.01. What is the ratio of the Balance of Payment (as % of commercial service exports) of West Bank and Gaza in 2008 to that in 2010?
Keep it short and to the point. 0.78. What is the ratio of the Balance of Payment (as % of commercial service exports) of Cameroon in 2008 to that in 2011?
Keep it short and to the point. 0.51. What is the ratio of the Balance of Payment (as % of commercial service exports) in South Africa in 2008 to that in 2011?
Offer a terse response. 1.04. What is the ratio of the Balance of Payment (as % of commercial service exports) in West Bank and Gaza in 2008 to that in 2011?
Your answer should be very brief. 0.74. What is the ratio of the Balance of Payment (as % of commercial service exports) in Cameroon in 2008 to that in 2012?
Provide a short and direct response. 0.51. What is the ratio of the Balance of Payment (as % of commercial service exports) in South Africa in 2008 to that in 2012?
Make the answer very short. 1.01. What is the ratio of the Balance of Payment (as % of commercial service exports) in West Bank and Gaza in 2008 to that in 2012?
Keep it short and to the point. 0.77. What is the ratio of the Balance of Payment (as % of commercial service exports) in Cameroon in 2009 to that in 2010?
Your answer should be compact. 1.84. What is the ratio of the Balance of Payment (as % of commercial service exports) of South Africa in 2009 to that in 2010?
Provide a short and direct response. 1.02. What is the ratio of the Balance of Payment (as % of commercial service exports) in West Bank and Gaza in 2009 to that in 2010?
Provide a succinct answer. 0.87. What is the ratio of the Balance of Payment (as % of commercial service exports) of Cameroon in 2009 to that in 2011?
Offer a very short reply. 1.05. What is the ratio of the Balance of Payment (as % of commercial service exports) in South Africa in 2009 to that in 2011?
Your answer should be compact. 1.06. What is the ratio of the Balance of Payment (as % of commercial service exports) of West Bank and Gaza in 2009 to that in 2011?
Keep it short and to the point. 0.83. What is the ratio of the Balance of Payment (as % of commercial service exports) in Cameroon in 2009 to that in 2012?
Offer a terse response. 1.05. What is the ratio of the Balance of Payment (as % of commercial service exports) of South Africa in 2009 to that in 2012?
Provide a short and direct response. 1.02. What is the ratio of the Balance of Payment (as % of commercial service exports) of West Bank and Gaza in 2009 to that in 2012?
Offer a terse response. 0.86. What is the ratio of the Balance of Payment (as % of commercial service exports) of Cameroon in 2010 to that in 2011?
Your answer should be very brief. 0.57. What is the ratio of the Balance of Payment (as % of commercial service exports) in South Africa in 2010 to that in 2011?
Make the answer very short. 1.03. What is the ratio of the Balance of Payment (as % of commercial service exports) of West Bank and Gaza in 2010 to that in 2011?
Offer a very short reply. 0.95. What is the ratio of the Balance of Payment (as % of commercial service exports) of Cameroon in 2010 to that in 2012?
Offer a very short reply. 0.57. What is the ratio of the Balance of Payment (as % of commercial service exports) in South Africa in 2011 to that in 2012?
Give a very brief answer. 0.97. What is the ratio of the Balance of Payment (as % of commercial service exports) of West Bank and Gaza in 2011 to that in 2012?
Make the answer very short. 1.04. What is the difference between the highest and the second highest Balance of Payment (as % of commercial service exports) in Cameroon?
Your answer should be compact. 1.03. What is the difference between the highest and the second highest Balance of Payment (as % of commercial service exports) of South Africa?
Offer a terse response. 1.31. What is the difference between the highest and the second highest Balance of Payment (as % of commercial service exports) in West Bank and Gaza?
Keep it short and to the point. 3.22. What is the difference between the highest and the lowest Balance of Payment (as % of commercial service exports) of Cameroon?
Offer a terse response. 12.14. What is the difference between the highest and the lowest Balance of Payment (as % of commercial service exports) in South Africa?
Your response must be concise. 8.83. What is the difference between the highest and the lowest Balance of Payment (as % of commercial service exports) in West Bank and Gaza?
Make the answer very short. 50.82. 